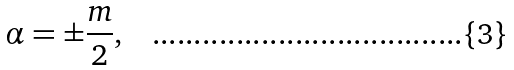Convert formula to latex. <formula><loc_0><loc_0><loc_500><loc_500>\alpha = \pm \frac { m } { 2 } ,</formula> 